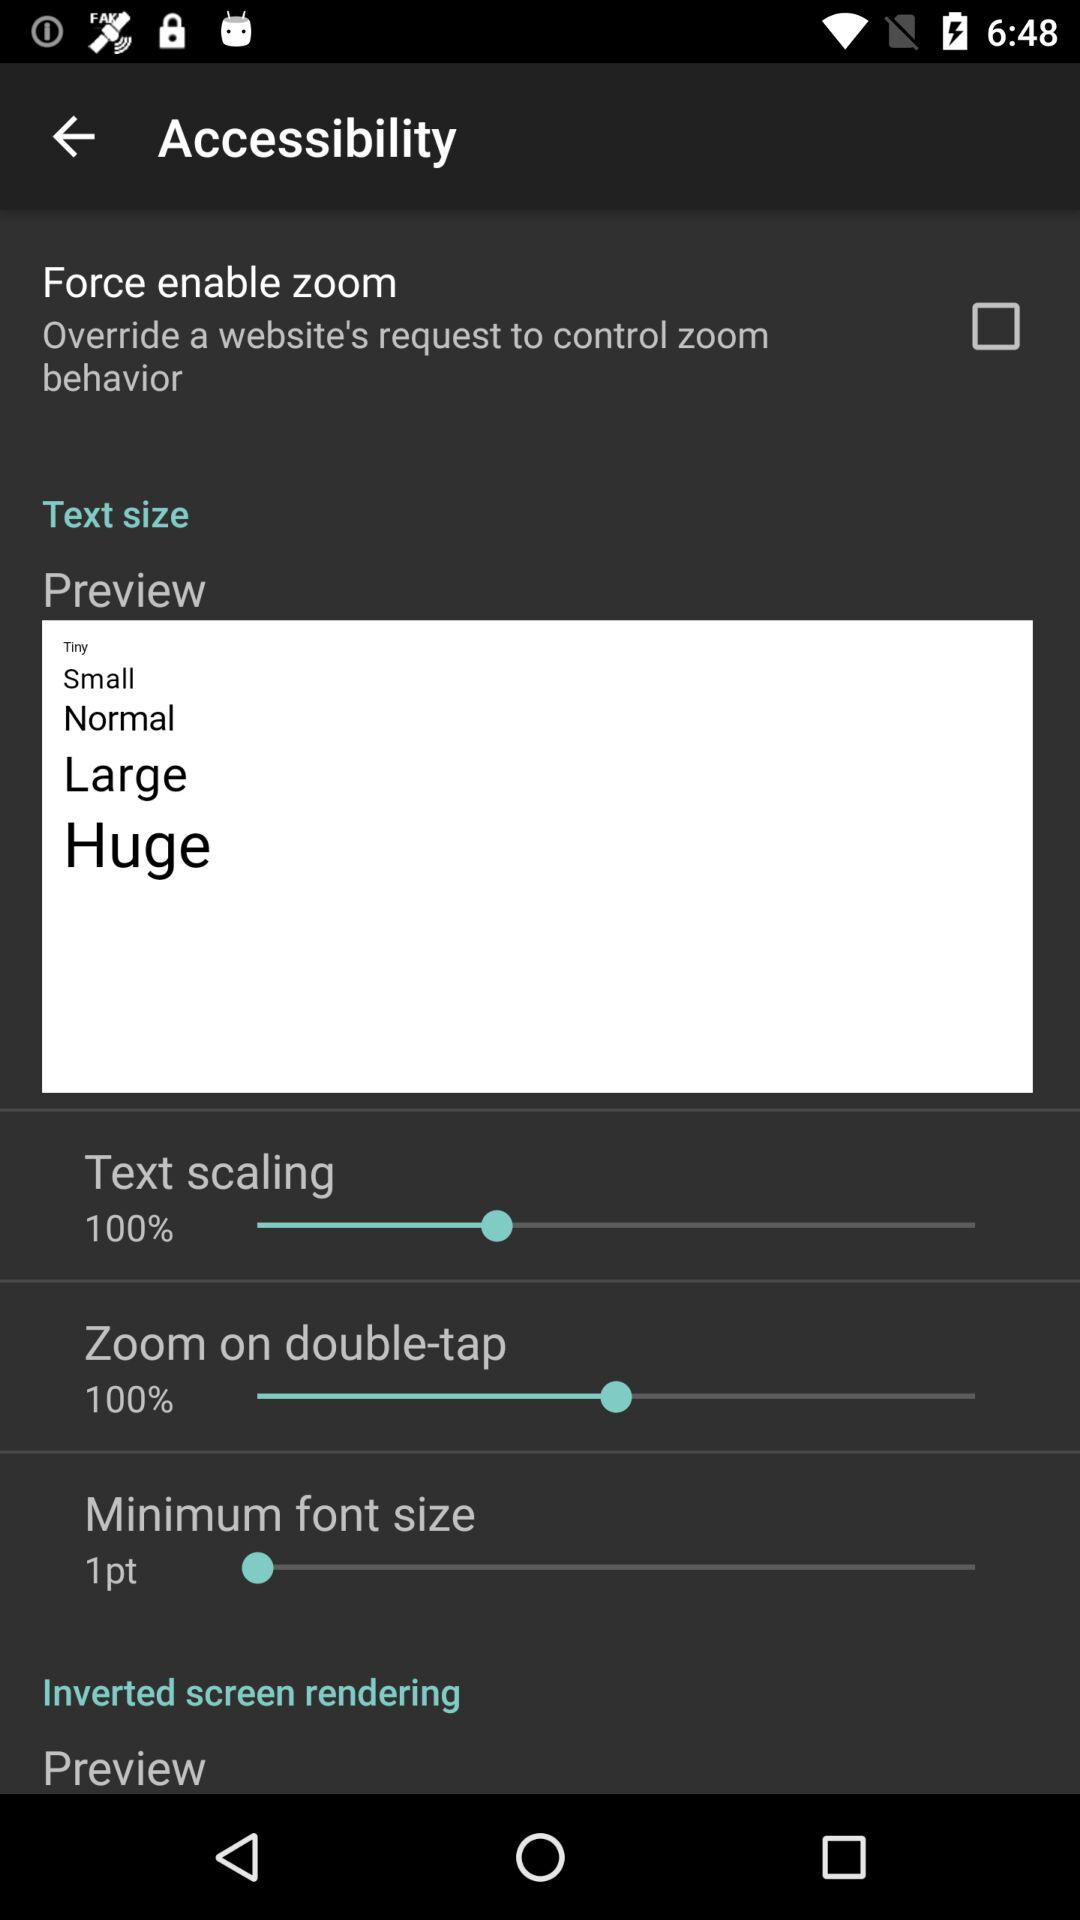What is the current status of "Force enable zoom"? The current status is "off". 